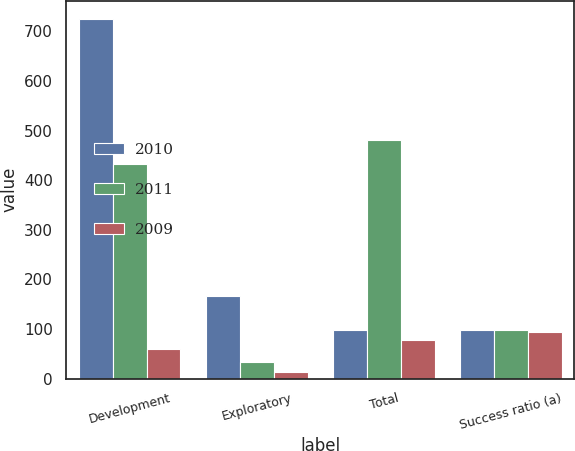Convert chart. <chart><loc_0><loc_0><loc_500><loc_500><stacked_bar_chart><ecel><fcel>Development<fcel>Exploratory<fcel>Total<fcel>Success ratio (a)<nl><fcel>2010<fcel>725<fcel>167<fcel>99<fcel>99<nl><fcel>2011<fcel>433<fcel>34<fcel>481<fcel>99<nl><fcel>2009<fcel>60<fcel>13<fcel>78<fcel>95<nl></chart> 